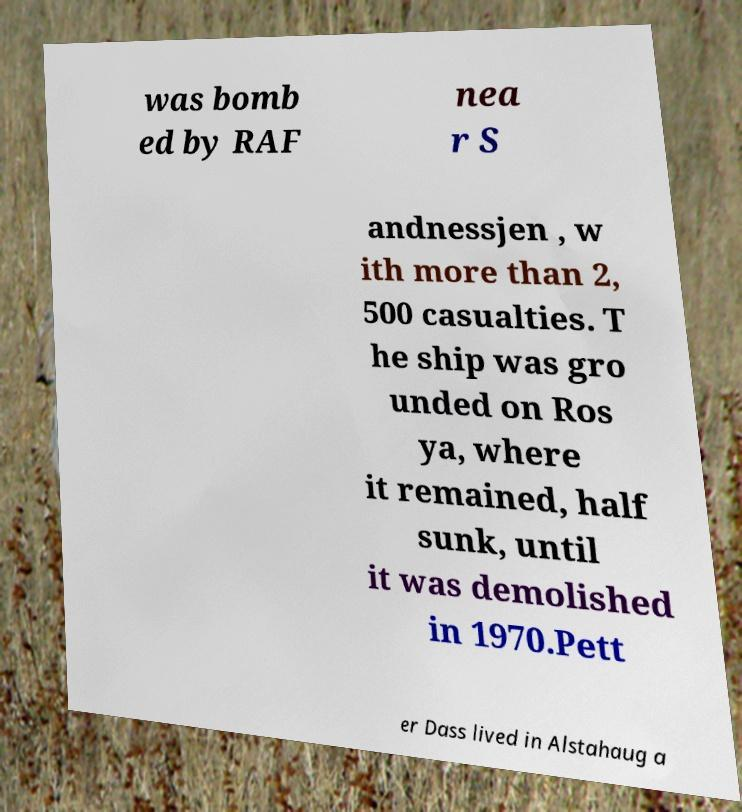Could you assist in decoding the text presented in this image and type it out clearly? was bomb ed by RAF nea r S andnessjen , w ith more than 2, 500 casualties. T he ship was gro unded on Ros ya, where it remained, half sunk, until it was demolished in 1970.Pett er Dass lived in Alstahaug a 